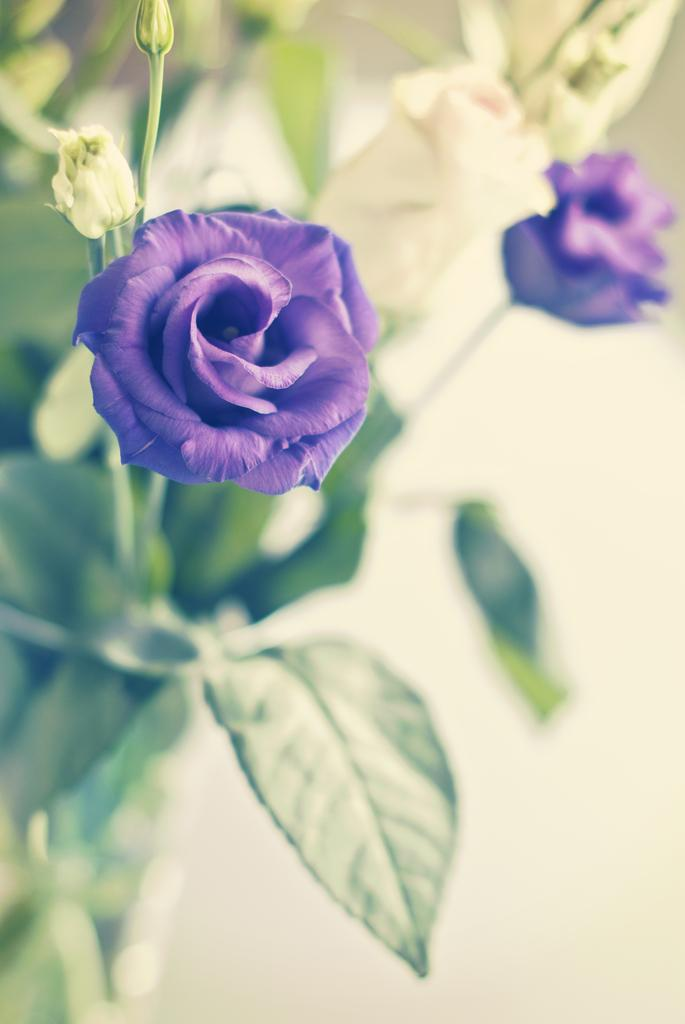How many flowers are visible in the image? There are two flowers in the image. Where are the flowers located? The flowers are on a plant. What is the position of the flowers in the image? The flowers are in the middle of the image. What type of meat can be seen hanging from the plant in the image? There is no meat present in the image; it features two flowers on a plant. How much money is visible in the image? There is no money present in the image; it features two flowers on a plant. 